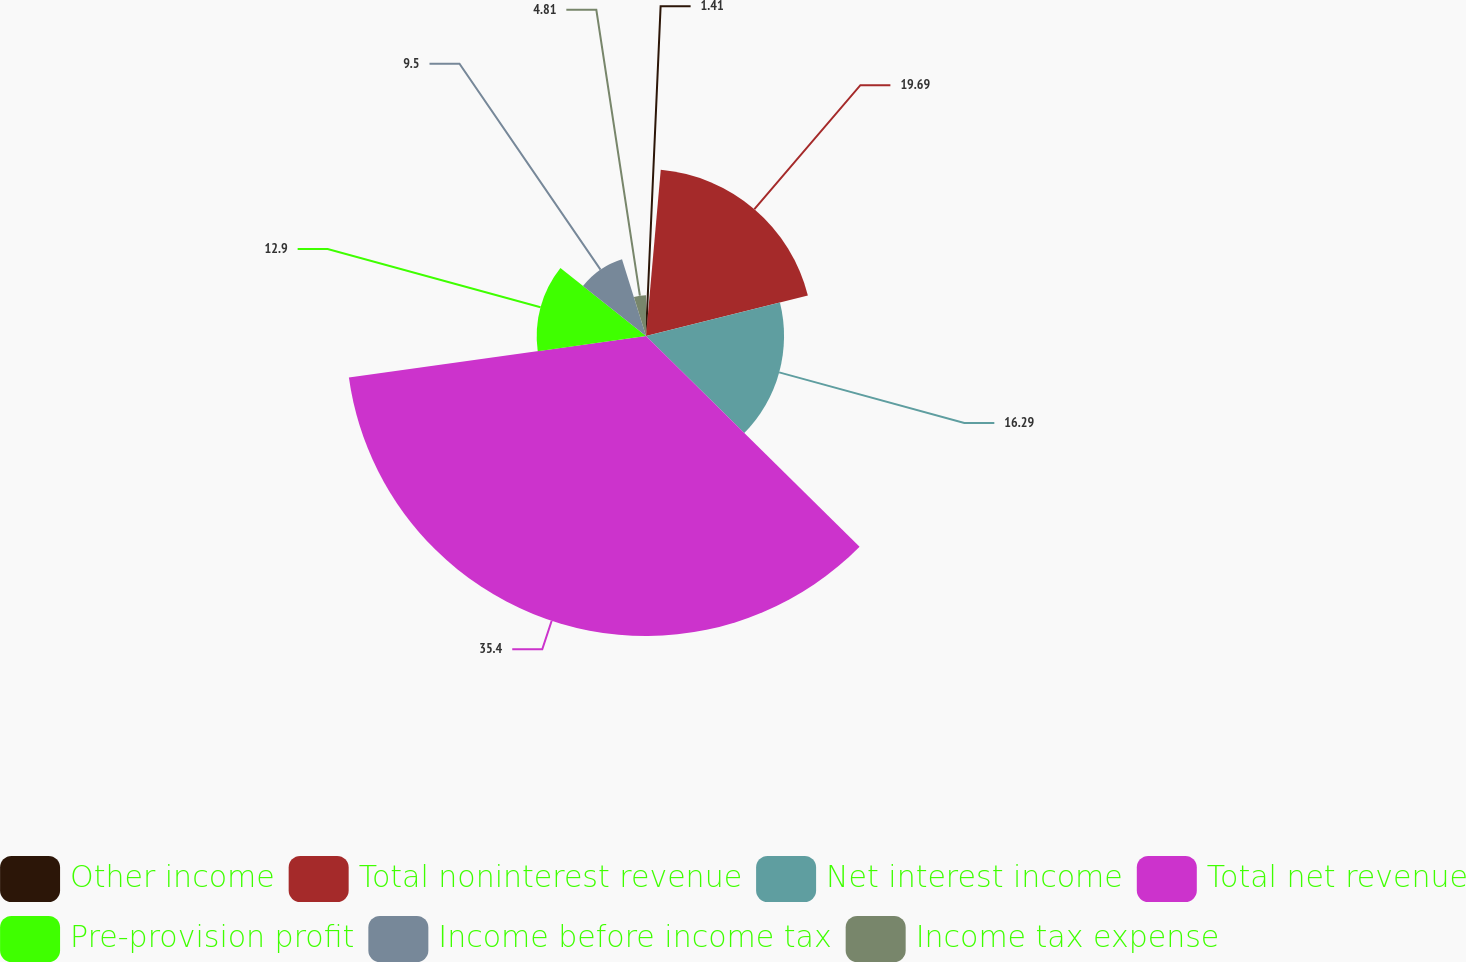<chart> <loc_0><loc_0><loc_500><loc_500><pie_chart><fcel>Other income<fcel>Total noninterest revenue<fcel>Net interest income<fcel>Total net revenue<fcel>Pre-provision profit<fcel>Income before income tax<fcel>Income tax expense<nl><fcel>1.41%<fcel>19.69%<fcel>16.29%<fcel>35.4%<fcel>12.9%<fcel>9.5%<fcel>4.81%<nl></chart> 